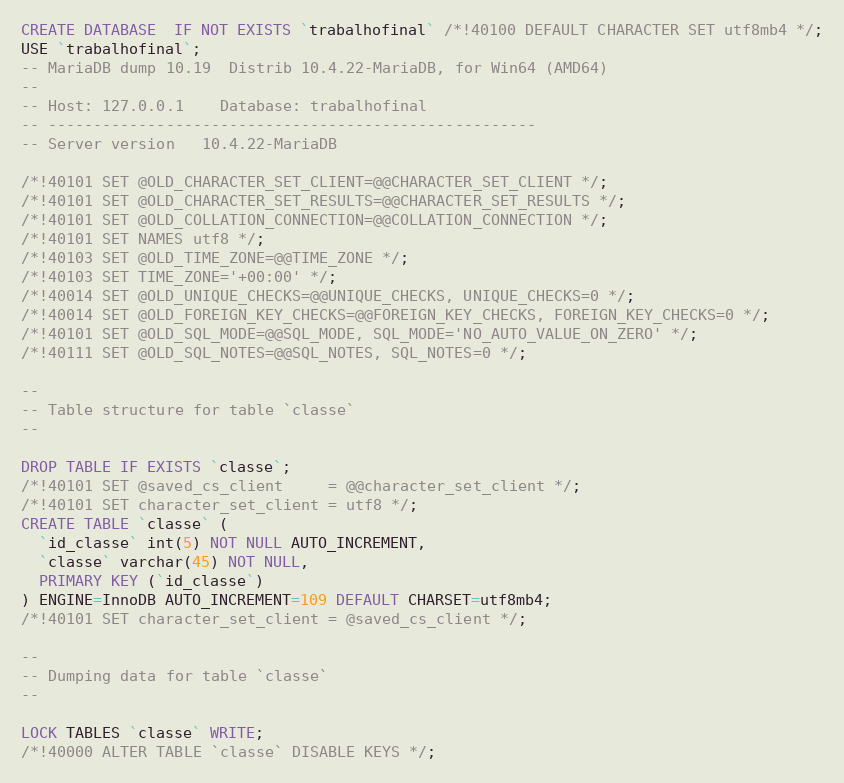Convert code to text. <code><loc_0><loc_0><loc_500><loc_500><_SQL_>CREATE DATABASE  IF NOT EXISTS `trabalhofinal` /*!40100 DEFAULT CHARACTER SET utf8mb4 */;
USE `trabalhofinal`;
-- MariaDB dump 10.19  Distrib 10.4.22-MariaDB, for Win64 (AMD64)
--
-- Host: 127.0.0.1    Database: trabalhofinal
-- ------------------------------------------------------
-- Server version	10.4.22-MariaDB

/*!40101 SET @OLD_CHARACTER_SET_CLIENT=@@CHARACTER_SET_CLIENT */;
/*!40101 SET @OLD_CHARACTER_SET_RESULTS=@@CHARACTER_SET_RESULTS */;
/*!40101 SET @OLD_COLLATION_CONNECTION=@@COLLATION_CONNECTION */;
/*!40101 SET NAMES utf8 */;
/*!40103 SET @OLD_TIME_ZONE=@@TIME_ZONE */;
/*!40103 SET TIME_ZONE='+00:00' */;
/*!40014 SET @OLD_UNIQUE_CHECKS=@@UNIQUE_CHECKS, UNIQUE_CHECKS=0 */;
/*!40014 SET @OLD_FOREIGN_KEY_CHECKS=@@FOREIGN_KEY_CHECKS, FOREIGN_KEY_CHECKS=0 */;
/*!40101 SET @OLD_SQL_MODE=@@SQL_MODE, SQL_MODE='NO_AUTO_VALUE_ON_ZERO' */;
/*!40111 SET @OLD_SQL_NOTES=@@SQL_NOTES, SQL_NOTES=0 */;

--
-- Table structure for table `classe`
--

DROP TABLE IF EXISTS `classe`;
/*!40101 SET @saved_cs_client     = @@character_set_client */;
/*!40101 SET character_set_client = utf8 */;
CREATE TABLE `classe` (
  `id_classe` int(5) NOT NULL AUTO_INCREMENT,
  `classe` varchar(45) NOT NULL,
  PRIMARY KEY (`id_classe`)
) ENGINE=InnoDB AUTO_INCREMENT=109 DEFAULT CHARSET=utf8mb4;
/*!40101 SET character_set_client = @saved_cs_client */;

--
-- Dumping data for table `classe`
--

LOCK TABLES `classe` WRITE;
/*!40000 ALTER TABLE `classe` DISABLE KEYS */;</code> 